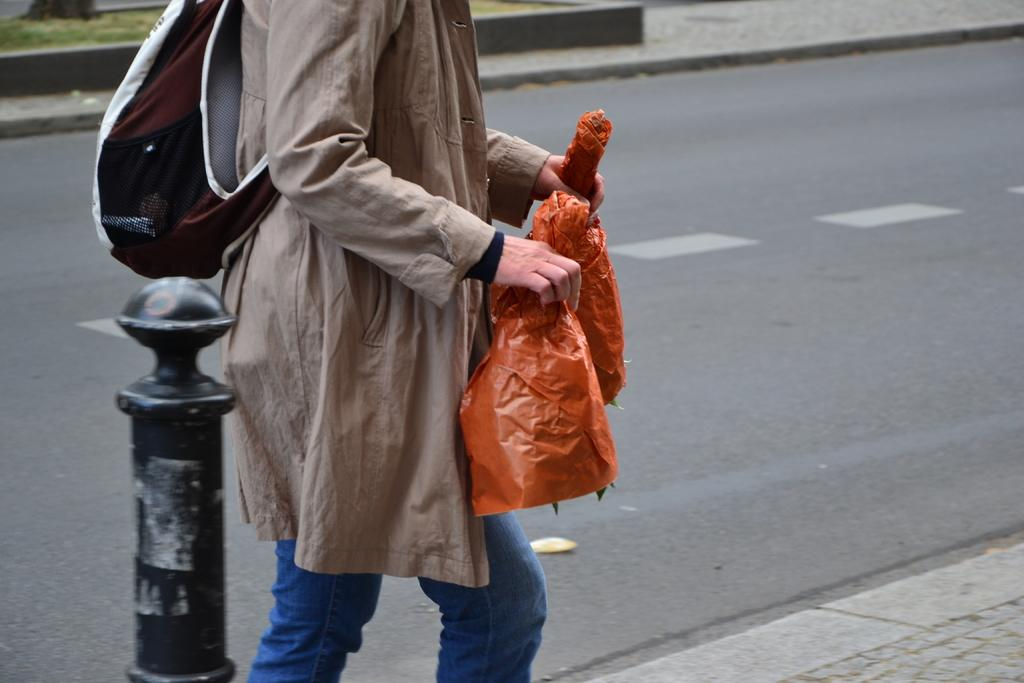What is the person in the image doing? The person is walking on the road in the image. What is the person carrying while walking? The person is holding an object. Can you describe the person's attire? The person is wearing a bag. What can be seen behind the person? There is a pole behind the person. What type of surface is visible in the background of the image? There is grass on the surface in the background of the image. What type of kettle is hanging from the pole in the image? There is no kettle present in the image; the pole is behind the person walking on the road. How does the person's stocking contribute to their sense of style in the image? The provided facts do not mention any stockings, so we cannot determine how they contribute to the person's sense of style. 